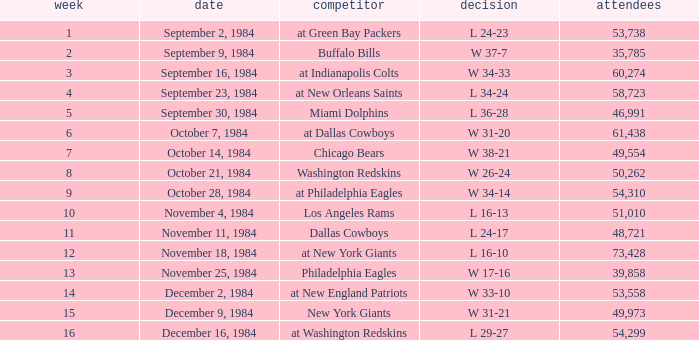What was the result in a week lower than 10 with an opponent of Chicago Bears? W 38-21. 